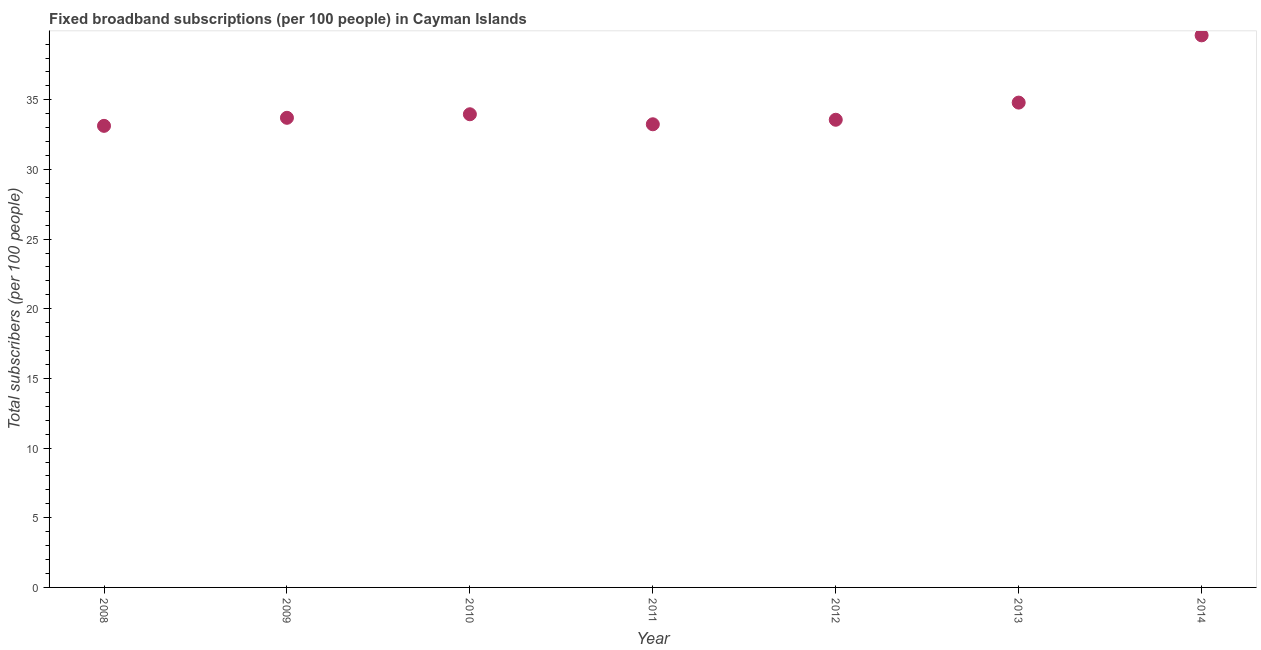What is the total number of fixed broadband subscriptions in 2009?
Offer a very short reply. 33.71. Across all years, what is the maximum total number of fixed broadband subscriptions?
Your answer should be compact. 39.63. Across all years, what is the minimum total number of fixed broadband subscriptions?
Your response must be concise. 33.13. In which year was the total number of fixed broadband subscriptions minimum?
Provide a succinct answer. 2008. What is the sum of the total number of fixed broadband subscriptions?
Give a very brief answer. 242.04. What is the difference between the total number of fixed broadband subscriptions in 2009 and 2010?
Provide a short and direct response. -0.25. What is the average total number of fixed broadband subscriptions per year?
Ensure brevity in your answer.  34.58. What is the median total number of fixed broadband subscriptions?
Offer a very short reply. 33.71. In how many years, is the total number of fixed broadband subscriptions greater than 35 ?
Provide a succinct answer. 1. What is the ratio of the total number of fixed broadband subscriptions in 2011 to that in 2013?
Your answer should be very brief. 0.96. Is the difference between the total number of fixed broadband subscriptions in 2011 and 2014 greater than the difference between any two years?
Keep it short and to the point. No. What is the difference between the highest and the second highest total number of fixed broadband subscriptions?
Make the answer very short. 4.83. Is the sum of the total number of fixed broadband subscriptions in 2008 and 2010 greater than the maximum total number of fixed broadband subscriptions across all years?
Ensure brevity in your answer.  Yes. What is the difference between the highest and the lowest total number of fixed broadband subscriptions?
Give a very brief answer. 6.5. In how many years, is the total number of fixed broadband subscriptions greater than the average total number of fixed broadband subscriptions taken over all years?
Offer a very short reply. 2. How many years are there in the graph?
Provide a succinct answer. 7. What is the difference between two consecutive major ticks on the Y-axis?
Give a very brief answer. 5. Does the graph contain any zero values?
Your answer should be compact. No. Does the graph contain grids?
Your response must be concise. No. What is the title of the graph?
Provide a succinct answer. Fixed broadband subscriptions (per 100 people) in Cayman Islands. What is the label or title of the X-axis?
Make the answer very short. Year. What is the label or title of the Y-axis?
Ensure brevity in your answer.  Total subscribers (per 100 people). What is the Total subscribers (per 100 people) in 2008?
Offer a very short reply. 33.13. What is the Total subscribers (per 100 people) in 2009?
Provide a short and direct response. 33.71. What is the Total subscribers (per 100 people) in 2010?
Make the answer very short. 33.96. What is the Total subscribers (per 100 people) in 2011?
Provide a short and direct response. 33.24. What is the Total subscribers (per 100 people) in 2012?
Your response must be concise. 33.57. What is the Total subscribers (per 100 people) in 2013?
Offer a terse response. 34.8. What is the Total subscribers (per 100 people) in 2014?
Your answer should be compact. 39.63. What is the difference between the Total subscribers (per 100 people) in 2008 and 2009?
Ensure brevity in your answer.  -0.58. What is the difference between the Total subscribers (per 100 people) in 2008 and 2010?
Your response must be concise. -0.83. What is the difference between the Total subscribers (per 100 people) in 2008 and 2011?
Provide a short and direct response. -0.11. What is the difference between the Total subscribers (per 100 people) in 2008 and 2012?
Ensure brevity in your answer.  -0.44. What is the difference between the Total subscribers (per 100 people) in 2008 and 2013?
Offer a terse response. -1.67. What is the difference between the Total subscribers (per 100 people) in 2008 and 2014?
Provide a succinct answer. -6.5. What is the difference between the Total subscribers (per 100 people) in 2009 and 2010?
Your answer should be compact. -0.25. What is the difference between the Total subscribers (per 100 people) in 2009 and 2011?
Offer a very short reply. 0.46. What is the difference between the Total subscribers (per 100 people) in 2009 and 2012?
Your answer should be compact. 0.14. What is the difference between the Total subscribers (per 100 people) in 2009 and 2013?
Make the answer very short. -1.09. What is the difference between the Total subscribers (per 100 people) in 2009 and 2014?
Your answer should be compact. -5.92. What is the difference between the Total subscribers (per 100 people) in 2010 and 2011?
Your answer should be very brief. 0.72. What is the difference between the Total subscribers (per 100 people) in 2010 and 2012?
Offer a very short reply. 0.39. What is the difference between the Total subscribers (per 100 people) in 2010 and 2013?
Your answer should be compact. -0.84. What is the difference between the Total subscribers (per 100 people) in 2010 and 2014?
Keep it short and to the point. -5.66. What is the difference between the Total subscribers (per 100 people) in 2011 and 2012?
Provide a short and direct response. -0.32. What is the difference between the Total subscribers (per 100 people) in 2011 and 2013?
Offer a terse response. -1.56. What is the difference between the Total subscribers (per 100 people) in 2011 and 2014?
Offer a very short reply. -6.38. What is the difference between the Total subscribers (per 100 people) in 2012 and 2013?
Provide a short and direct response. -1.23. What is the difference between the Total subscribers (per 100 people) in 2012 and 2014?
Your answer should be very brief. -6.06. What is the difference between the Total subscribers (per 100 people) in 2013 and 2014?
Make the answer very short. -4.83. What is the ratio of the Total subscribers (per 100 people) in 2008 to that in 2010?
Make the answer very short. 0.98. What is the ratio of the Total subscribers (per 100 people) in 2008 to that in 2011?
Offer a terse response. 1. What is the ratio of the Total subscribers (per 100 people) in 2008 to that in 2014?
Provide a short and direct response. 0.84. What is the ratio of the Total subscribers (per 100 people) in 2009 to that in 2014?
Your answer should be compact. 0.85. What is the ratio of the Total subscribers (per 100 people) in 2010 to that in 2011?
Your response must be concise. 1.02. What is the ratio of the Total subscribers (per 100 people) in 2010 to that in 2013?
Keep it short and to the point. 0.98. What is the ratio of the Total subscribers (per 100 people) in 2010 to that in 2014?
Provide a succinct answer. 0.86. What is the ratio of the Total subscribers (per 100 people) in 2011 to that in 2012?
Your answer should be compact. 0.99. What is the ratio of the Total subscribers (per 100 people) in 2011 to that in 2013?
Provide a succinct answer. 0.95. What is the ratio of the Total subscribers (per 100 people) in 2011 to that in 2014?
Offer a terse response. 0.84. What is the ratio of the Total subscribers (per 100 people) in 2012 to that in 2013?
Make the answer very short. 0.96. What is the ratio of the Total subscribers (per 100 people) in 2012 to that in 2014?
Offer a terse response. 0.85. What is the ratio of the Total subscribers (per 100 people) in 2013 to that in 2014?
Give a very brief answer. 0.88. 